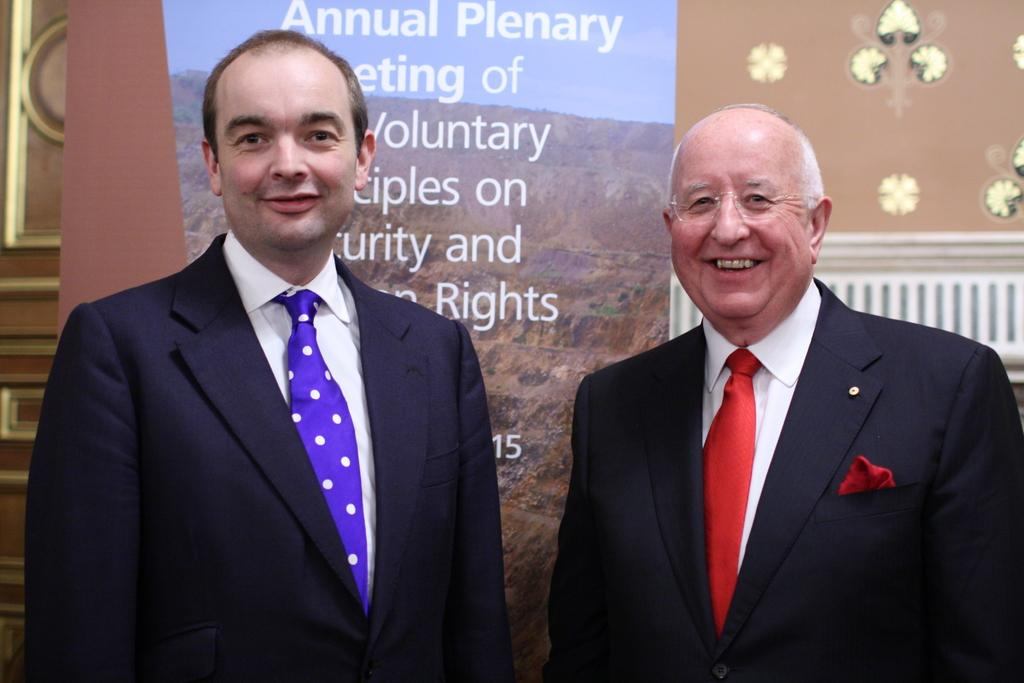What can be seen in the image? There are men standing in the image. How are the men in the image depicted? The men are smiling. What is visible in the background of the image? There is an advertising element and a wall in the background of the image. How many ministers are present in the image? There is no mention of ministers in the image; it features men standing and smiling. What type of wax can be seen in the image? There is no wax present in the image. 